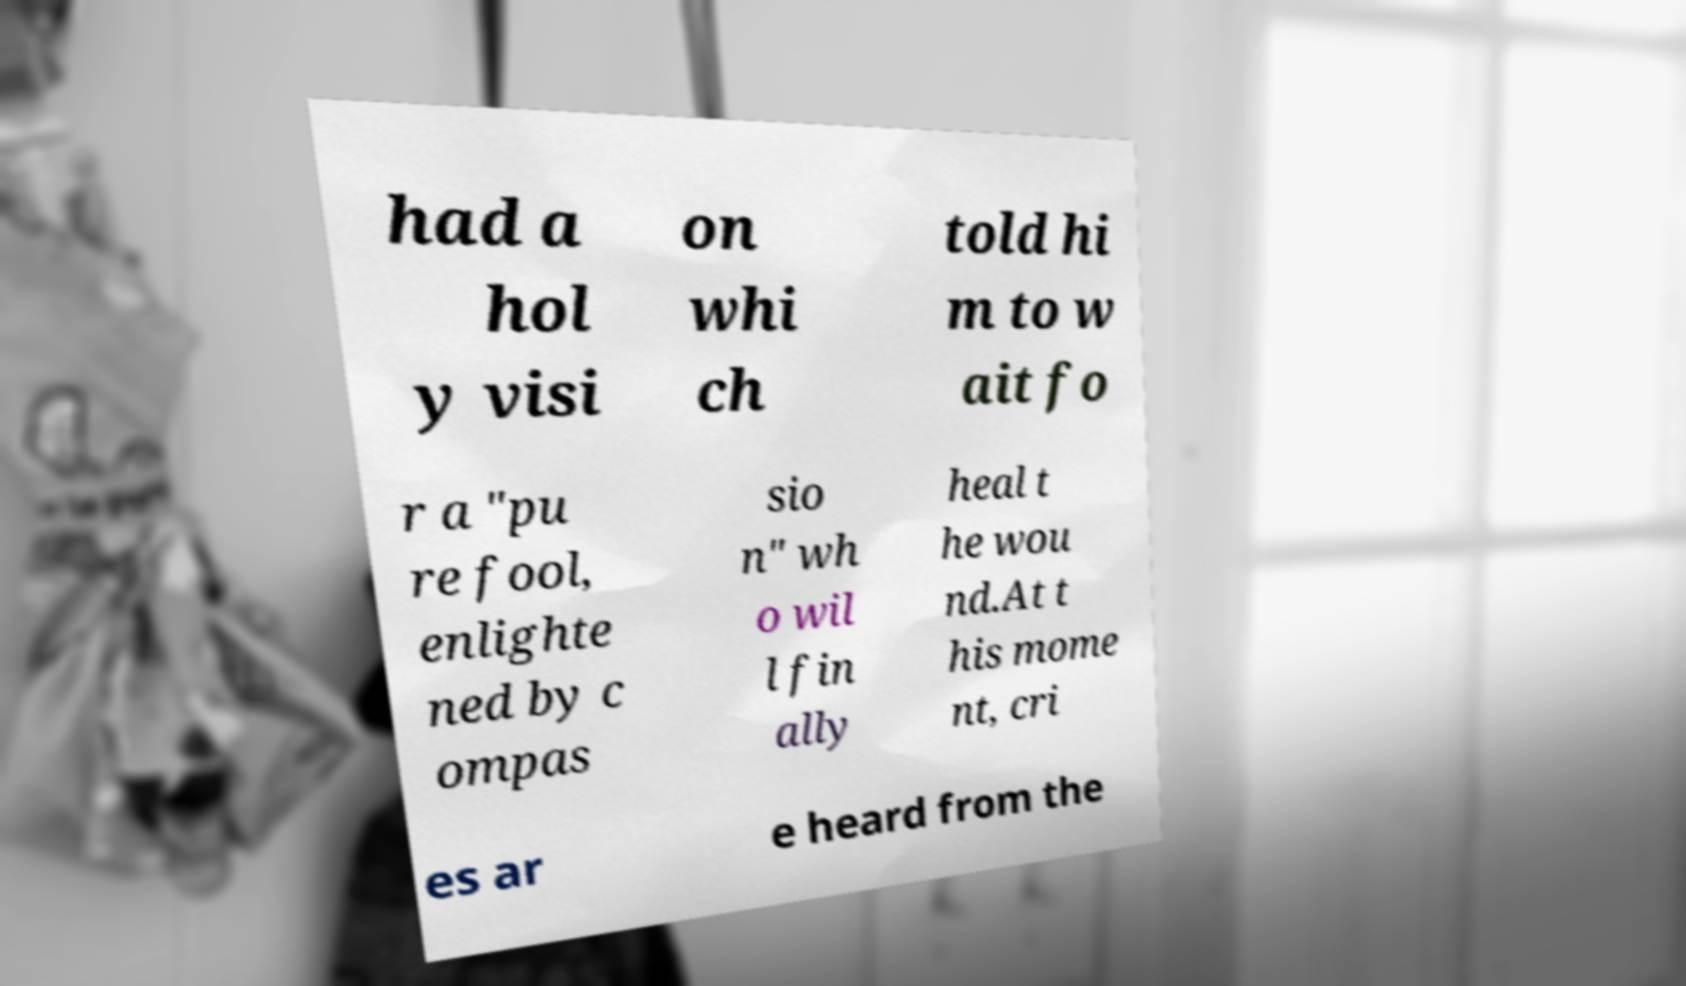Could you extract and type out the text from this image? had a hol y visi on whi ch told hi m to w ait fo r a "pu re fool, enlighte ned by c ompas sio n" wh o wil l fin ally heal t he wou nd.At t his mome nt, cri es ar e heard from the 